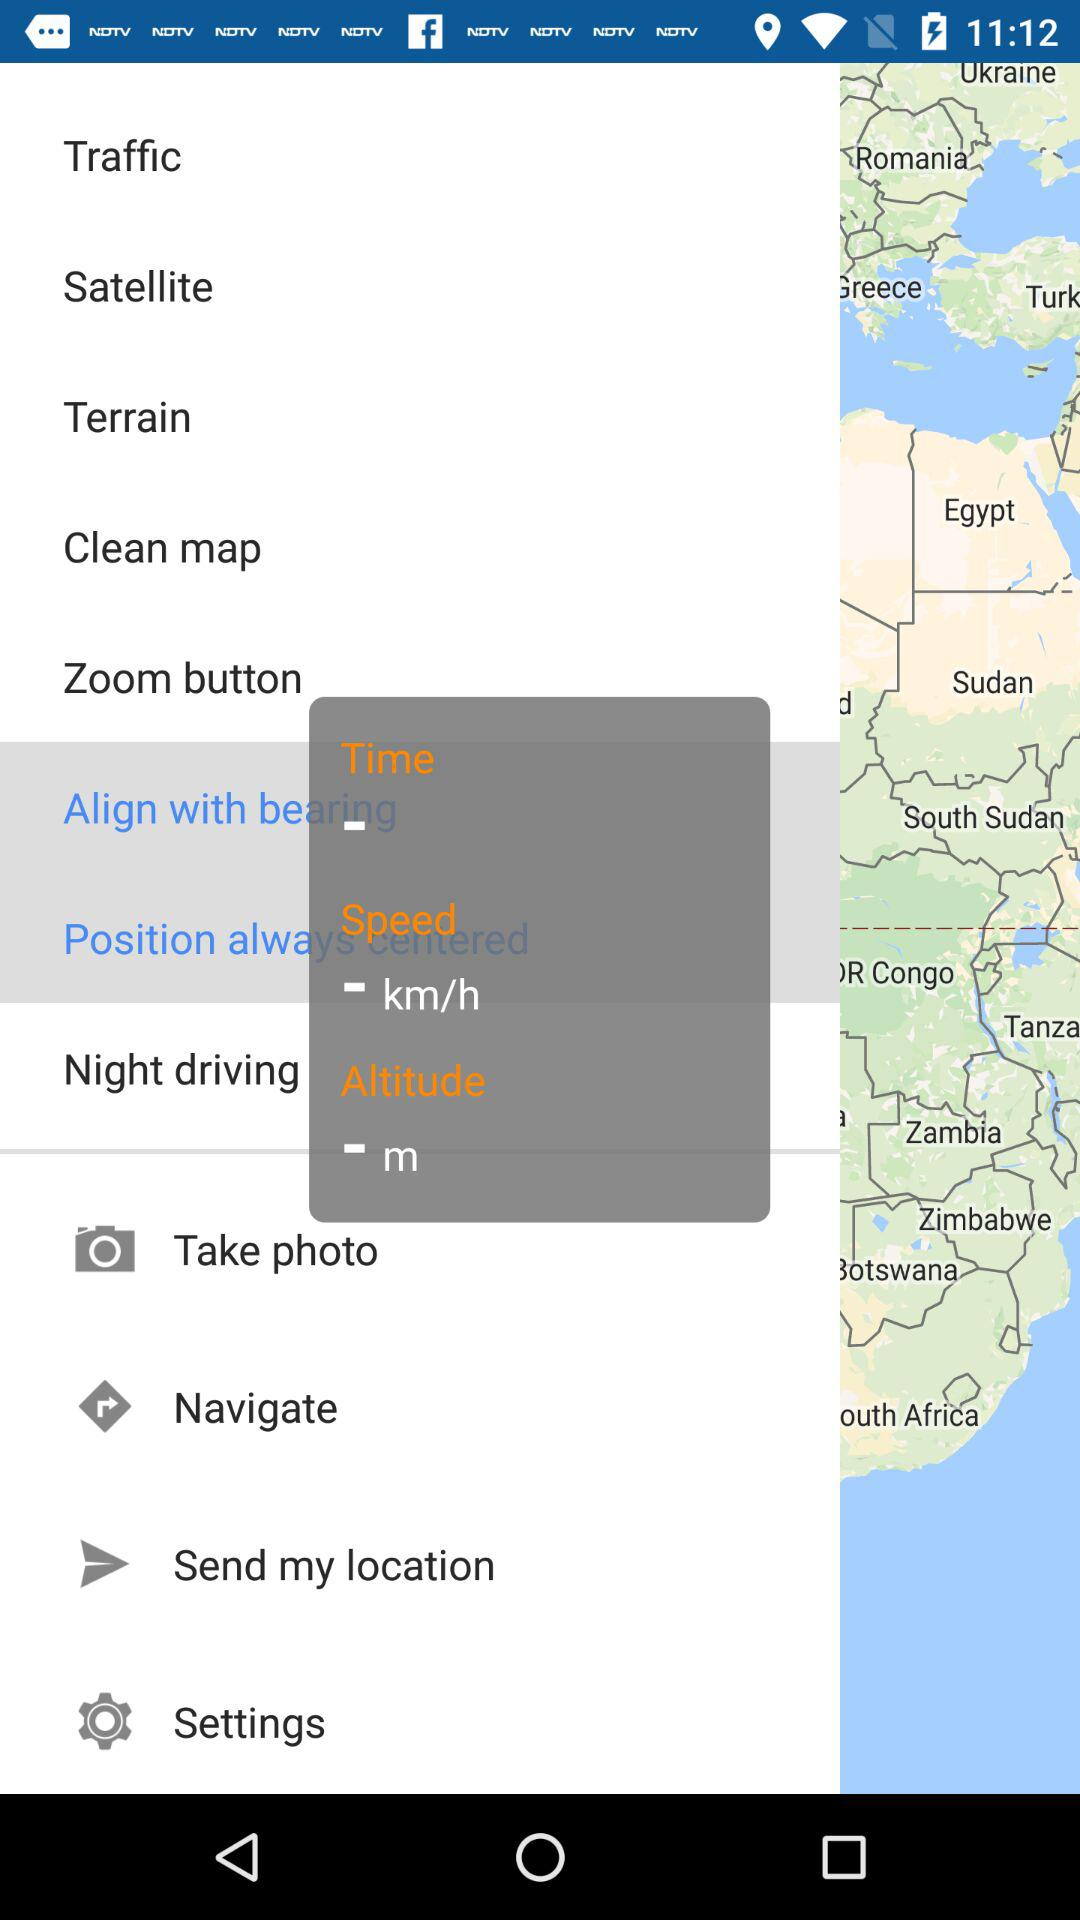What is the measuring unit for speed? The measuring unit for speed is km/h. 